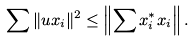Convert formula to latex. <formula><loc_0><loc_0><loc_500><loc_500>\sum \| u x _ { i } \| ^ { 2 } \leq \left \| \sum x ^ { * } _ { i } x _ { i } \right \| .</formula> 